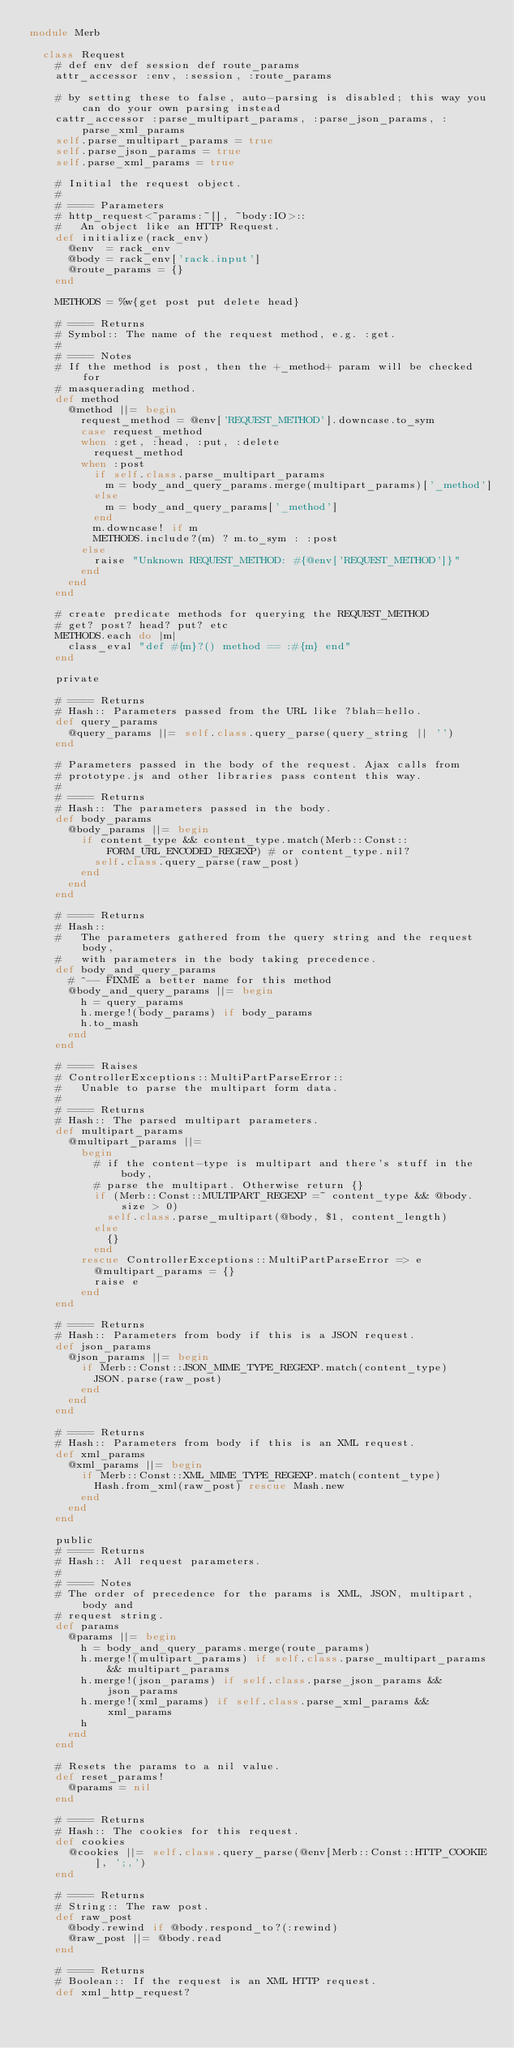Convert code to text. <code><loc_0><loc_0><loc_500><loc_500><_Ruby_>module Merb
  
  class Request
    # def env def session def route_params
    attr_accessor :env, :session, :route_params
    
    # by setting these to false, auto-parsing is disabled; this way you can do your own parsing instead
    cattr_accessor :parse_multipart_params, :parse_json_params, :parse_xml_params
    self.parse_multipart_params = true
    self.parse_json_params = true
    self.parse_xml_params = true
    
    # Initial the request object.
    #
    # ==== Parameters
    # http_request<~params:~[], ~body:IO>:: 
    #   An object like an HTTP Request.
    def initialize(rack_env)
      @env  = rack_env
      @body = rack_env['rack.input']
      @route_params = {}
    end
    
    METHODS = %w{get post put delete head}

    # ==== Returns
    # Symbol:: The name of the request method, e.g. :get.
    #
    # ==== Notes
    # If the method is post, then the +_method+ param will be checked for
    # masquerading method.
    def method
      @method ||= begin
        request_method = @env['REQUEST_METHOD'].downcase.to_sym
        case request_method
        when :get, :head, :put, :delete
          request_method
        when :post
          if self.class.parse_multipart_params
            m = body_and_query_params.merge(multipart_params)['_method']
          else  
            m = body_and_query_params['_method']
          end
          m.downcase! if m
          METHODS.include?(m) ? m.to_sym : :post
        else
          raise "Unknown REQUEST_METHOD: #{@env['REQUEST_METHOD']}"
        end
      end
    end
    
    # create predicate methods for querying the REQUEST_METHOD
    # get? post? head? put? etc
    METHODS.each do |m|
      class_eval "def #{m}?() method == :#{m} end"
    end
    
    private
    
    # ==== Returns
    # Hash:: Parameters passed from the URL like ?blah=hello.
    def query_params
      @query_params ||= self.class.query_parse(query_string || '')
    end
    
    # Parameters passed in the body of the request. Ajax calls from
    # prototype.js and other libraries pass content this way.
    #
    # ==== Returns
    # Hash:: The parameters passed in the body.
    def body_params
      @body_params ||= begin
        if content_type && content_type.match(Merb::Const::FORM_URL_ENCODED_REGEXP) # or content_type.nil?
          self.class.query_parse(raw_post)
        end
      end
    end

    # ==== Returns
    # Hash::
    #   The parameters gathered from the query string and the request body,
    #   with parameters in the body taking precedence.
    def body_and_query_params
      # ^-- FIXME a better name for this method
      @body_and_query_params ||= begin
        h = query_params
        h.merge!(body_params) if body_params
        h.to_mash
      end
    end

    # ==== Raises
    # ControllerExceptions::MultiPartParseError::
    #   Unable to parse the multipart form data.
    #
    # ==== Returns
    # Hash:: The parsed multipart parameters.
    def multipart_params
      @multipart_params ||= 
        begin
          # if the content-type is multipart and there's stuff in the body,
          # parse the multipart. Otherwise return {}
          if (Merb::Const::MULTIPART_REGEXP =~ content_type && @body.size > 0)
            self.class.parse_multipart(@body, $1, content_length)
          else
            {}
          end  
        rescue ControllerExceptions::MultiPartParseError => e
          @multipart_params = {}
          raise e
        end
    end

    # ==== Returns
    # Hash:: Parameters from body if this is a JSON request.
    def json_params
      @json_params ||= begin
        if Merb::Const::JSON_MIME_TYPE_REGEXP.match(content_type)
          JSON.parse(raw_post)
        end
      end
    end

    # ==== Returns
    # Hash:: Parameters from body if this is an XML request.
    def xml_params
      @xml_params ||= begin
        if Merb::Const::XML_MIME_TYPE_REGEXP.match(content_type)
          Hash.from_xml(raw_post) rescue Mash.new
        end
      end
    end
    
    public
    # ==== Returns
    # Hash:: All request parameters.
    #
    # ==== Notes
    # The order of precedence for the params is XML, JSON, multipart, body and
    # request string.
    def params
      @params ||= begin
        h = body_and_query_params.merge(route_params)      
        h.merge!(multipart_params) if self.class.parse_multipart_params && multipart_params
        h.merge!(json_params) if self.class.parse_json_params && json_params
        h.merge!(xml_params) if self.class.parse_xml_params && xml_params
        h
      end
    end

    # Resets the params to a nil value.
    def reset_params!
      @params = nil
    end

    # ==== Returns
    # Hash:: The cookies for this request.
    def cookies
      @cookies ||= self.class.query_parse(@env[Merb::Const::HTTP_COOKIE], ';,')
    end

    # ==== Returns
    # String:: The raw post.
    def raw_post
      @body.rewind if @body.respond_to?(:rewind)
      @raw_post ||= @body.read
    end
    
    # ==== Returns
    # Boolean:: If the request is an XML HTTP request.
    def xml_http_request?</code> 